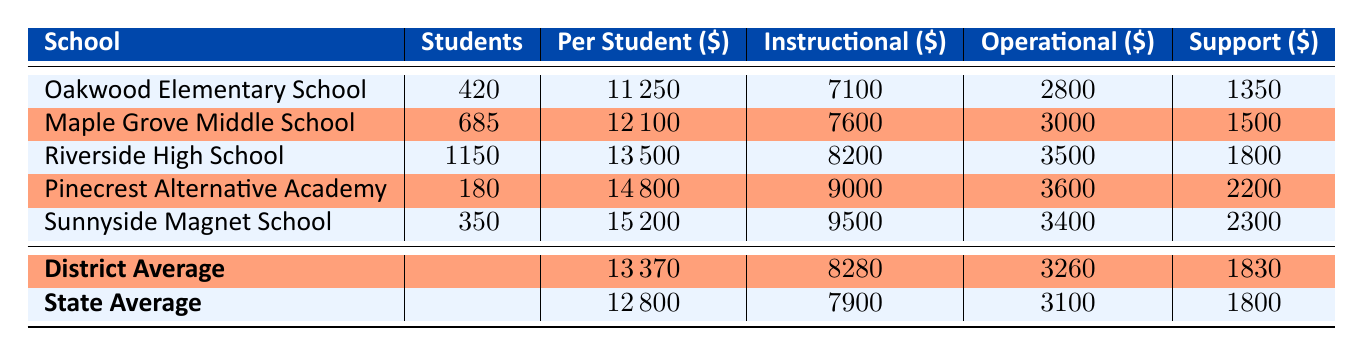What is the per-student expenditure at Riverside High School? The table lists the "Per Student" expenditure for Riverside High School, which is directly presented in the corresponding row. The value in that cell is 13500.
Answer: 13500 Which school has the highest per-student expenditure? By examining the "Per Student" column, we can see that Pinecrest Alternative Academy has the highest value at 14800.
Answer: Pinecrest Alternative Academy What is the average per-student expenditure for the district? The "District Average" row at the bottom of the table shows the average per-student expenditure, which is stated as 13370.
Answer: 13370 Is the per-student expenditure of Maple Grove Middle School higher than the state average? The per-student expenditure for Maple Grove Middle School is 12100, while the state average is 12800. Since 12100 is less than 12800, the answer is no.
Answer: No What is the total number of students across all the schools? We can find the total number of students by adding the values in the "Students" column: 420 + 685 + 1150 + 180 + 350 = 2885.
Answer: 2885 How much higher is the per-student expenditure at Sunnyside Magnet School compared to the district average? The per-student expenditure at Sunnyside Magnet School is 15200, and the district average is 13370. The difference is calculated by subtracting the average from the school's expenditure: 15200 - 13370 = 1830.
Answer: 1830 Which school has the lowest operational costs? Looking at the "Operational" column, we find that Oakwood Elementary School has the lowest operational costs, listed as 2800.
Answer: Oakwood Elementary School Is the instructional cost at Riverside High School above the district average for instructional costs? The instructional cost at Riverside High School is 8200, while the district average for instructional costs is 8280. Comparing these figures shows that 8200 is less than 8280, so the answer is no.
Answer: No What percentage of the total per-student expenditure at Pinecrest Alternative Academy is spent on support services? The per-student expenditure at Pinecrest is 14800, and support services cost 2200. To find the percentage: (2200 / 14800) * 100 = 14.86%.
Answer: 14.86% 